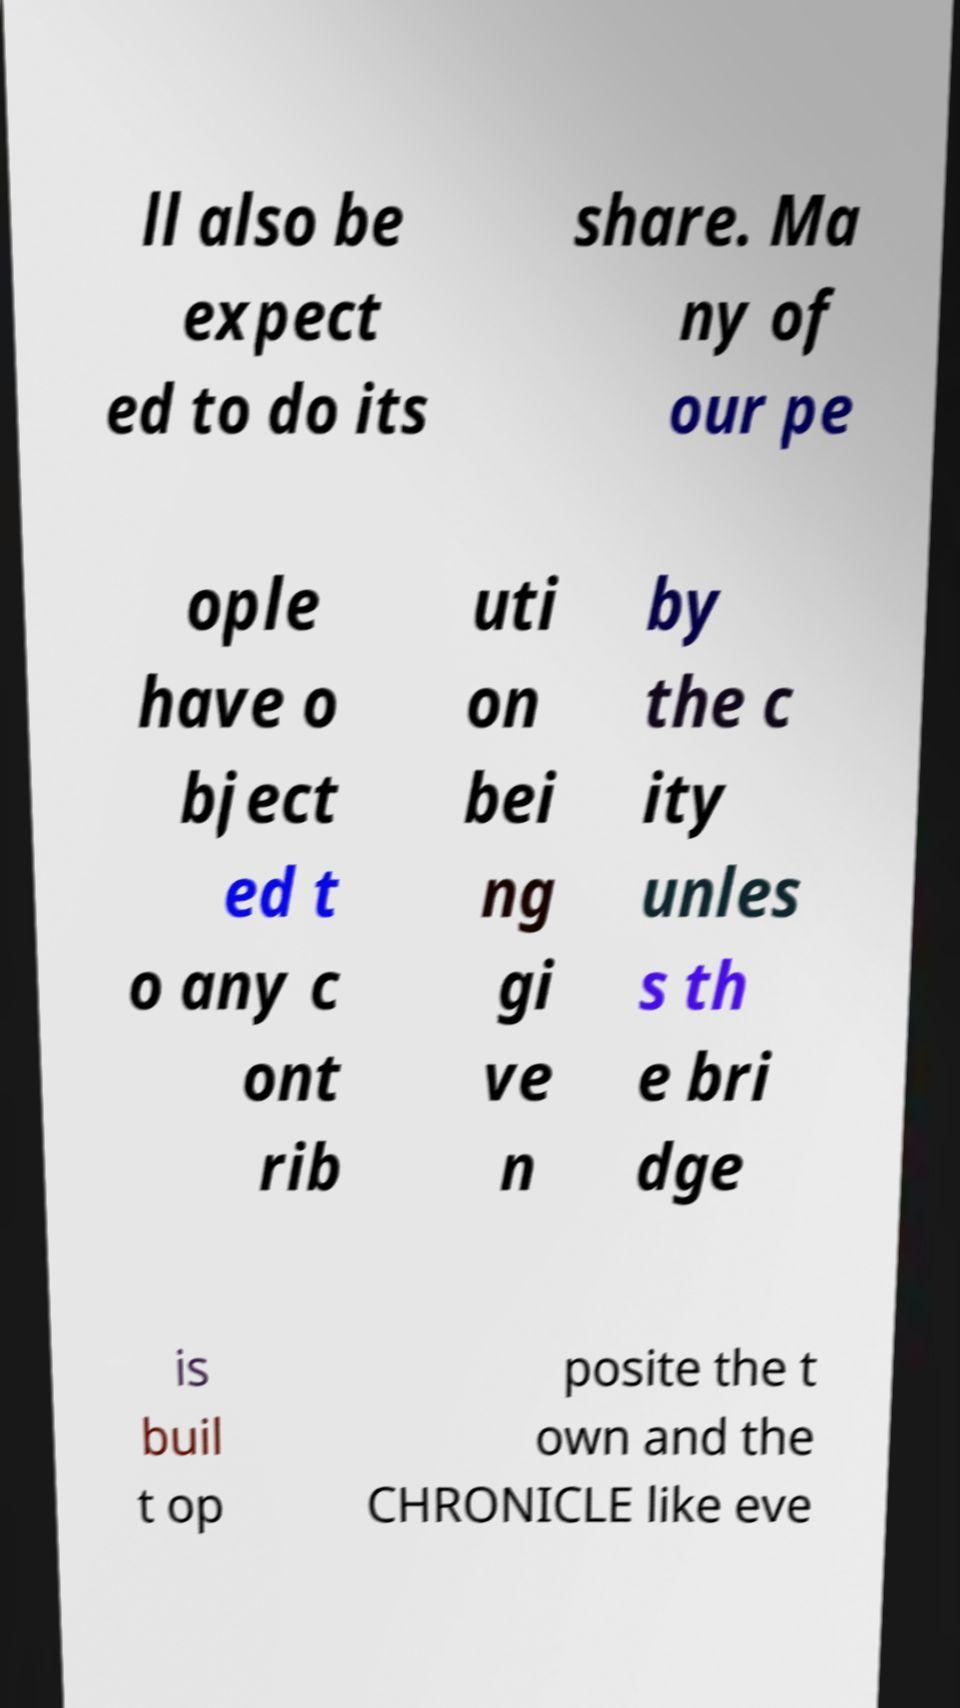Could you assist in decoding the text presented in this image and type it out clearly? ll also be expect ed to do its share. Ma ny of our pe ople have o bject ed t o any c ont rib uti on bei ng gi ve n by the c ity unles s th e bri dge is buil t op posite the t own and the CHRONICLE like eve 